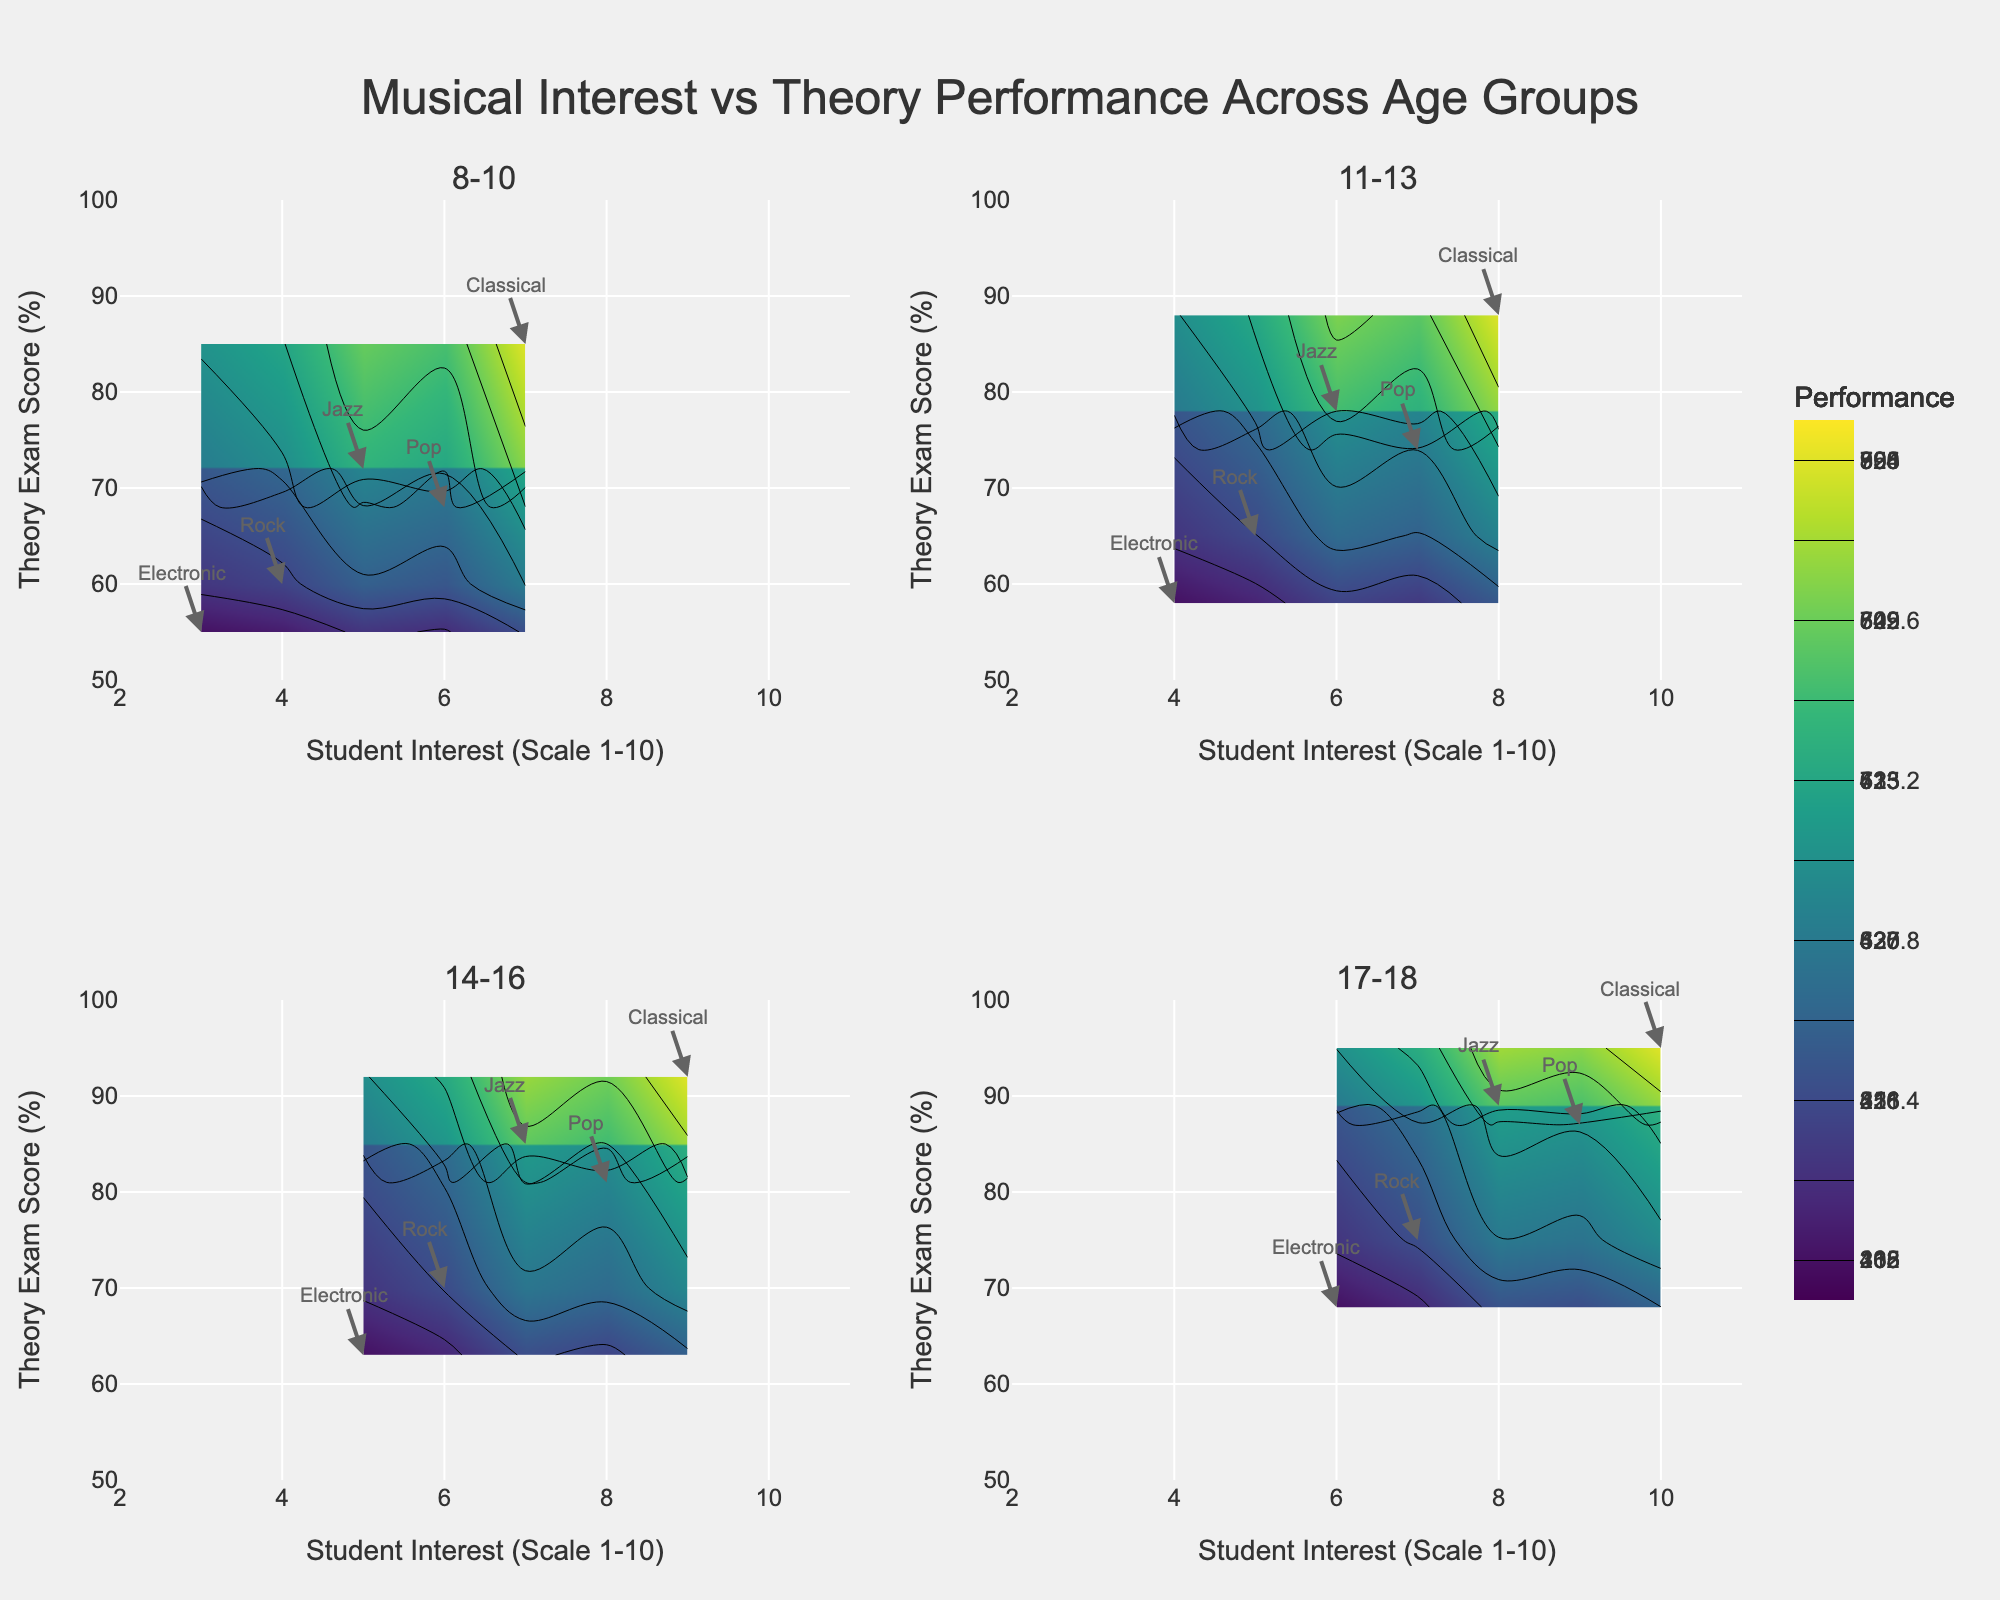How many age groups are represented in the figure? The subplot has four titles, each representing an age group.
Answer: Four What is the title of the figure? The title is displayed at the top center of the figure and reads "Musical Interest vs Theory Performance Across Age Groups".
Answer: Musical Interest vs Theory Performance Across Age Groups In the 8-10 age group, how does the interest in Classical music compare to Electronic music? Looking at the annotations for the 8-10 subplot, Classical has higher interest (7) compared to Electronic music (3).
Answer: Classical has higher interest Which age group has the highest theory exam score for Rock music? By examining the annotations in each subplot for Rock music, the highest score for Rock is in the 17-18 age group with a score of 75.
Answer: 17-18 What's the range of the Theory Exam Score axis in each subplot? Each subplot's y-axis ranges from 50% to 100%, as shown on the y-axes of the figure.
Answer: 50% to 100% Which musical genre is associated with the highest student interest in the 14-16 age group, and what is the corresponding theory exam score? By referring to the annotations in the 14-16 subplot, Classical music has the highest interest (9) with a theory exam score of 92%.
Answer: Classical, 92% Compare the student interest and theory exam score for Jazz music between the 11-13 and 17-18 age groups. In the 11-13 age group, Jazz has an interest of 6 and a score of 78%. In the 17-18 age group, Jazz has an interest of 8 and a score of 89%.
Answer: Interest and score are higher in the 17-18 age group Which age group shows the smallest difference in theory exam scores between Classical and Pop genres? For each age group, the differences are calculated as follows: 
8-10: 85-68 = 17 
11-13: 88-74 = 14 
14-16: 92-81 = 11 
17-18: 95-87 = 8 
The smallest difference is 8 in the 17-18 age group.
Answer: 17-18 What is the trend in student interest in Classical music across the age groups? Inspecting the annotations for Classical in each subplot reveals a steady increase: 
8-10: 7 
11-13: 8 
14-16: 9 
17-18: 10
Answer: Increasing with age 